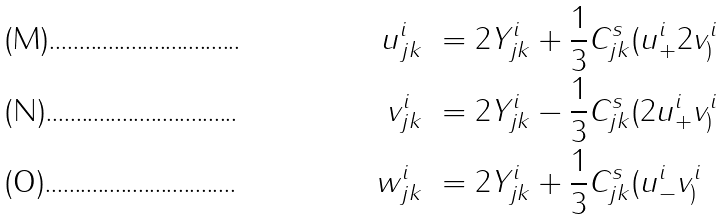Convert formula to latex. <formula><loc_0><loc_0><loc_500><loc_500>u ^ { i } _ { j k } & \ = 2 Y ^ { i } _ { j k } + \frac { 1 } { 3 } C ^ { s } _ { j k } ( u ^ { i } _ { + } 2 v ^ { i } _ { ) } \\ v ^ { i } _ { j k } & \ = 2 Y ^ { i } _ { j k } - \frac { 1 } { 3 } C ^ { s } _ { j k } ( 2 u ^ { i } _ { + } v ^ { i } _ { ) } \\ w ^ { i } _ { j k } & \ = 2 Y ^ { i } _ { j k } + \frac { 1 } { 3 } C ^ { s } _ { j k } ( u ^ { i } _ { - } v ^ { i } _ { ) }</formula> 